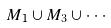Convert formula to latex. <formula><loc_0><loc_0><loc_500><loc_500>M _ { 1 } \cup M _ { 3 } \cup \cdot \cdot \cdot</formula> 